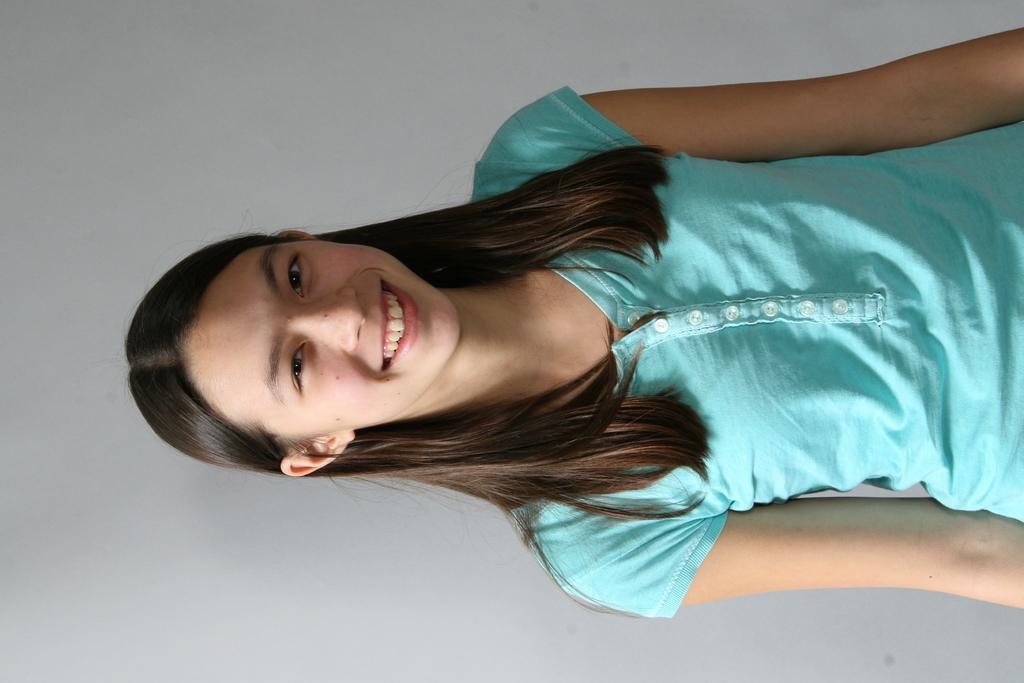Please provide a concise description of this image. In this image there is one girl standing and smiling as we can see in the middle of this image. There is a wall in the background. 